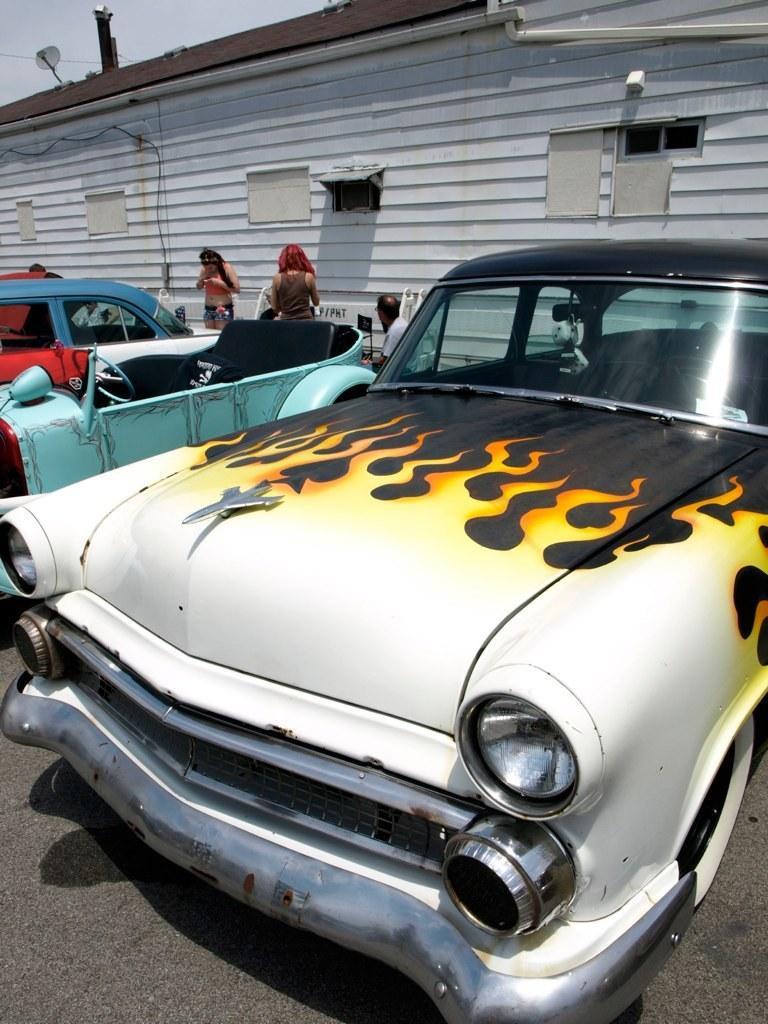In one or two sentences, can you explain what this image depicts? In front of the picture, we see the car in white, black and yellow color is moving on the road. Beside that, we see the cars which are in blue color are parked on the road. Behind the cars, we see two women are standing and the man is sitting. In the background, we see a building in white color with a brown color roof. We see the windows. In the left top, we see the dish cable and the sky. 